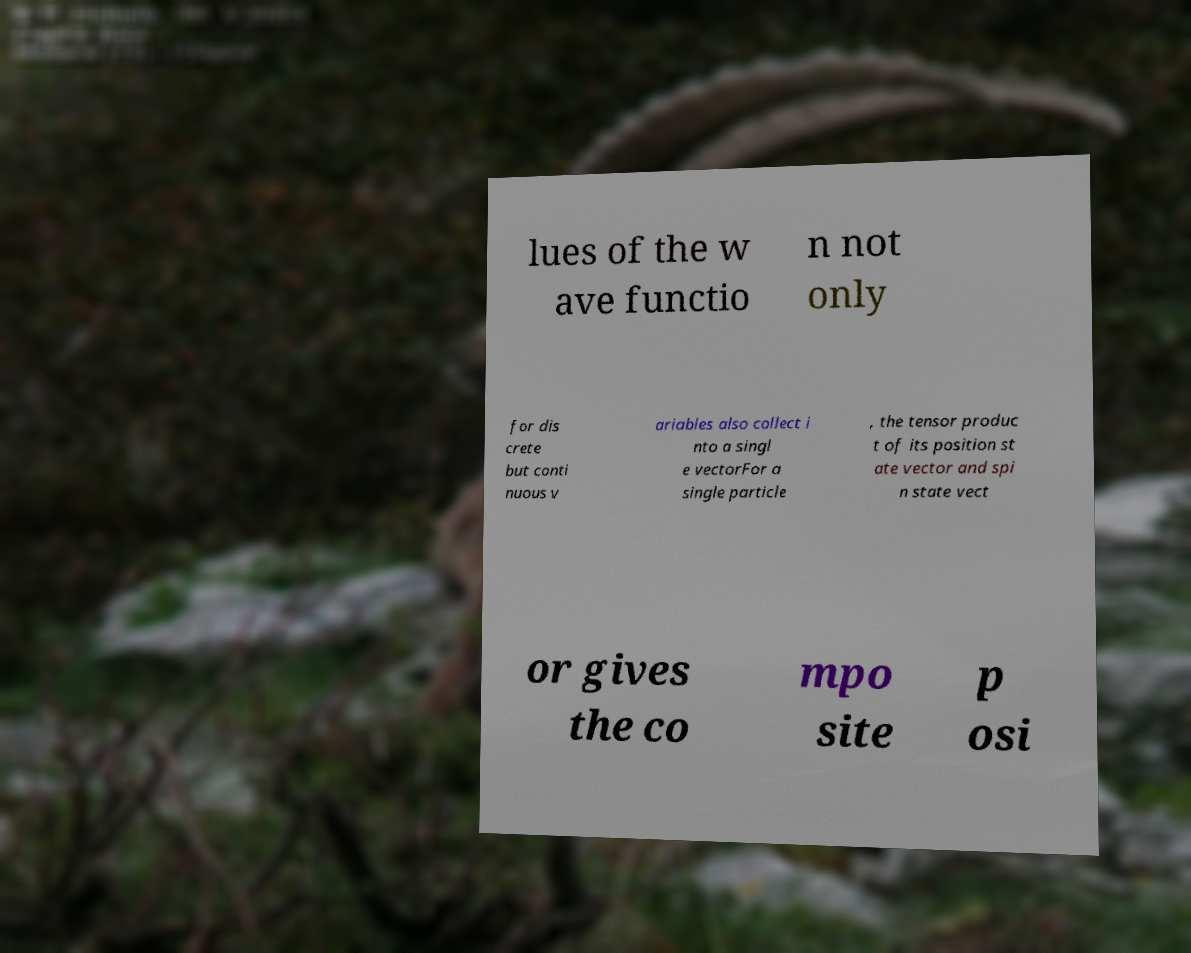Can you accurately transcribe the text from the provided image for me? lues of the w ave functio n not only for dis crete but conti nuous v ariables also collect i nto a singl e vectorFor a single particle , the tensor produc t of its position st ate vector and spi n state vect or gives the co mpo site p osi 